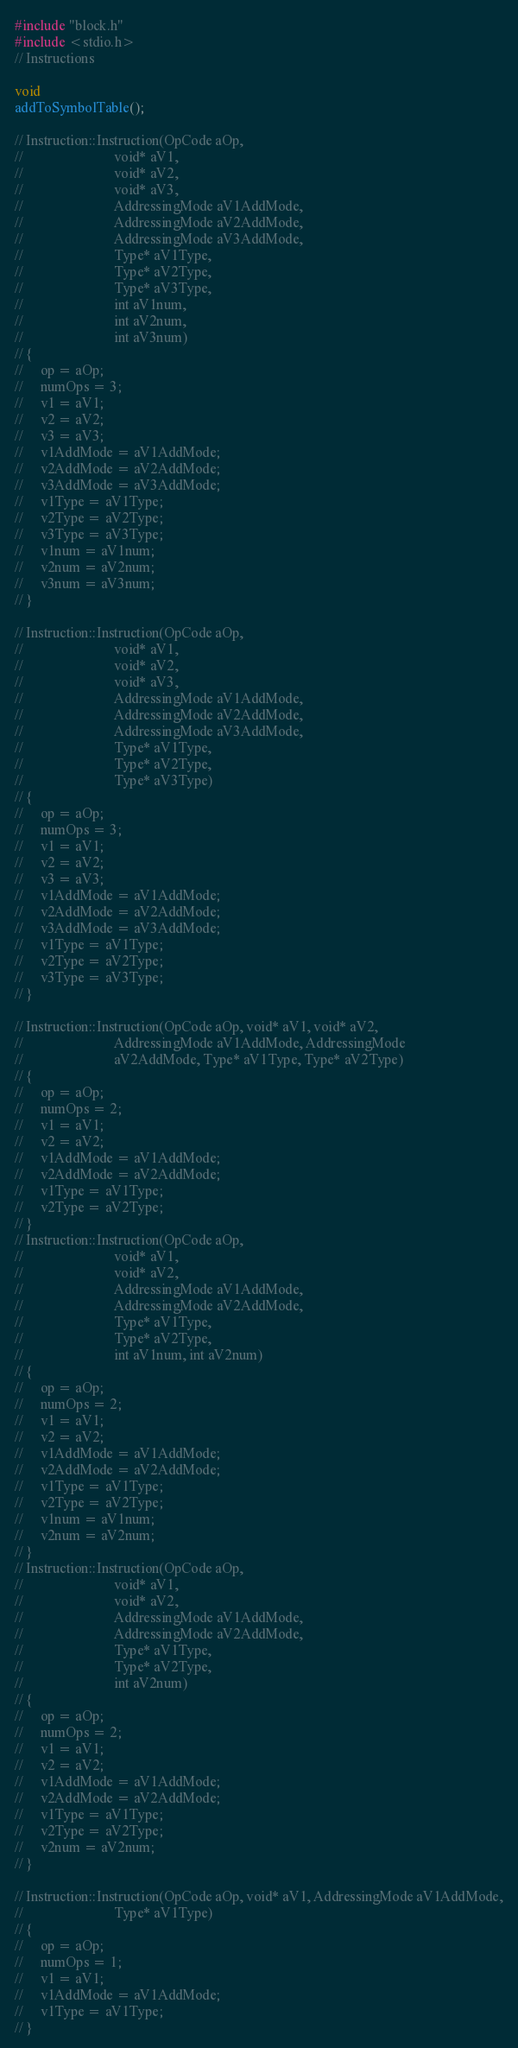<code> <loc_0><loc_0><loc_500><loc_500><_C++_>#include "block.h"
#include <stdio.h>
// Instructions

void
addToSymbolTable();

// Instruction::Instruction(OpCode aOp,
//                          void* aV1,
//                          void* aV2,
//                          void* aV3,
//                          AddressingMode aV1AddMode,
//                          AddressingMode aV2AddMode,
//                          AddressingMode aV3AddMode,
//                          Type* aV1Type,
//                          Type* aV2Type,
//                          Type* aV3Type,
//                          int aV1num,
//                          int aV2num,
//                          int aV3num)
// {
//     op = aOp;
//     numOps = 3;
//     v1 = aV1;
//     v2 = aV2;
//     v3 = aV3;
//     v1AddMode = aV1AddMode;
//     v2AddMode = aV2AddMode;
//     v3AddMode = aV3AddMode;
//     v1Type = aV1Type;
//     v2Type = aV2Type;
//     v3Type = aV3Type;
//     v1num = aV1num;
//     v2num = aV2num;
//     v3num = aV3num;
// }

// Instruction::Instruction(OpCode aOp,
//                          void* aV1,
//                          void* aV2,
//                          void* aV3,
//                          AddressingMode aV1AddMode,
//                          AddressingMode aV2AddMode,
//                          AddressingMode aV3AddMode,
//                          Type* aV1Type,
//                          Type* aV2Type,
//                          Type* aV3Type)
// {
//     op = aOp;
//     numOps = 3;
//     v1 = aV1;
//     v2 = aV2;
//     v3 = aV3;
//     v1AddMode = aV1AddMode;
//     v2AddMode = aV2AddMode;
//     v3AddMode = aV3AddMode;
//     v1Type = aV1Type;
//     v2Type = aV2Type;
//     v3Type = aV3Type;
// }

// Instruction::Instruction(OpCode aOp, void* aV1, void* aV2,
//                          AddressingMode aV1AddMode, AddressingMode
//                          aV2AddMode, Type* aV1Type, Type* aV2Type)
// {
//     op = aOp;
//     numOps = 2;
//     v1 = aV1;
//     v2 = aV2;
//     v1AddMode = aV1AddMode;
//     v2AddMode = aV2AddMode;
//     v1Type = aV1Type;
//     v2Type = aV2Type;
// }
// Instruction::Instruction(OpCode aOp,
//                          void* aV1,
//                          void* aV2,
//                          AddressingMode aV1AddMode,
//                          AddressingMode aV2AddMode,
//                          Type* aV1Type,
//                          Type* aV2Type,
//                          int aV1num, int aV2num)
// {
//     op = aOp;
//     numOps = 2;
//     v1 = aV1;
//     v2 = aV2;
//     v1AddMode = aV1AddMode;
//     v2AddMode = aV2AddMode;
//     v1Type = aV1Type;
//     v2Type = aV2Type;
//     v1num = aV1num;
//     v2num = aV2num;
// }
// Instruction::Instruction(OpCode aOp,
//                          void* aV1,
//                          void* aV2,
//                          AddressingMode aV1AddMode,
//                          AddressingMode aV2AddMode,
//                          Type* aV1Type,
//                          Type* aV2Type,
//                          int aV2num)
// {
//     op = aOp;
//     numOps = 2;
//     v1 = aV1;
//     v2 = aV2;
//     v1AddMode = aV1AddMode;
//     v2AddMode = aV2AddMode;
//     v1Type = aV1Type;
//     v2Type = aV2Type;
//     v2num = aV2num;
// }

// Instruction::Instruction(OpCode aOp, void* aV1, AddressingMode aV1AddMode,
//                          Type* aV1Type)
// {
//     op = aOp;
//     numOps = 1;
//     v1 = aV1;
//     v1AddMode = aV1AddMode;
//     v1Type = aV1Type;
// }
</code> 